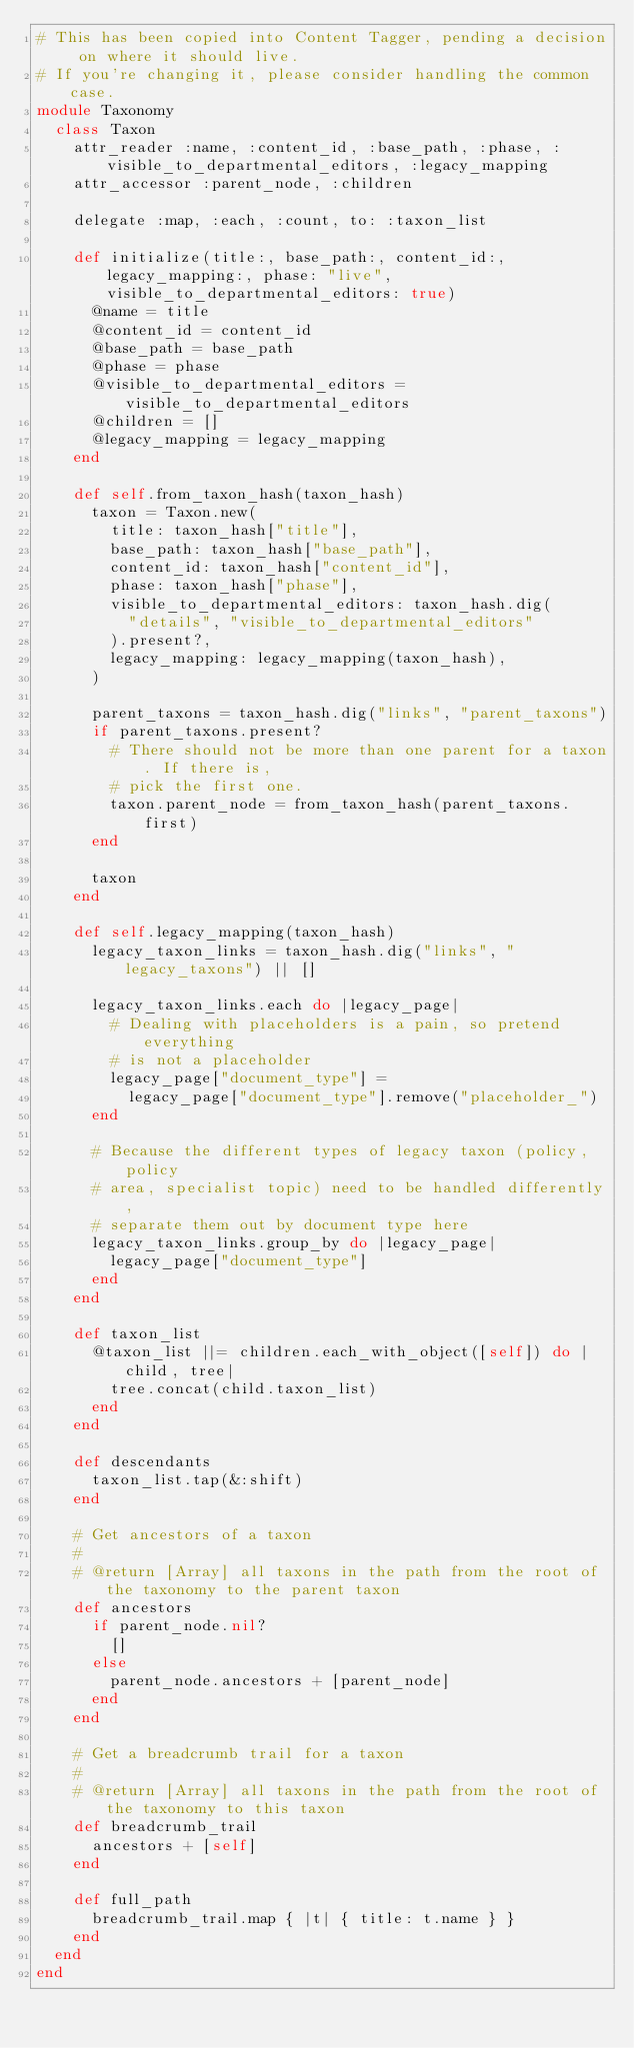Convert code to text. <code><loc_0><loc_0><loc_500><loc_500><_Ruby_># This has been copied into Content Tagger, pending a decision on where it should live.
# If you're changing it, please consider handling the common case.
module Taxonomy
  class Taxon
    attr_reader :name, :content_id, :base_path, :phase, :visible_to_departmental_editors, :legacy_mapping
    attr_accessor :parent_node, :children

    delegate :map, :each, :count, to: :taxon_list

    def initialize(title:, base_path:, content_id:, legacy_mapping:, phase: "live", visible_to_departmental_editors: true)
      @name = title
      @content_id = content_id
      @base_path = base_path
      @phase = phase
      @visible_to_departmental_editors = visible_to_departmental_editors
      @children = []
      @legacy_mapping = legacy_mapping
    end

    def self.from_taxon_hash(taxon_hash)
      taxon = Taxon.new(
        title: taxon_hash["title"],
        base_path: taxon_hash["base_path"],
        content_id: taxon_hash["content_id"],
        phase: taxon_hash["phase"],
        visible_to_departmental_editors: taxon_hash.dig(
          "details", "visible_to_departmental_editors"
        ).present?,
        legacy_mapping: legacy_mapping(taxon_hash),
      )

      parent_taxons = taxon_hash.dig("links", "parent_taxons")
      if parent_taxons.present?
        # There should not be more than one parent for a taxon. If there is,
        # pick the first one.
        taxon.parent_node = from_taxon_hash(parent_taxons.first)
      end

      taxon
    end

    def self.legacy_mapping(taxon_hash)
      legacy_taxon_links = taxon_hash.dig("links", "legacy_taxons") || []

      legacy_taxon_links.each do |legacy_page|
        # Dealing with placeholders is a pain, so pretend everything
        # is not a placeholder
        legacy_page["document_type"] =
          legacy_page["document_type"].remove("placeholder_")
      end

      # Because the different types of legacy taxon (policy, policy
      # area, specialist topic) need to be handled differently,
      # separate them out by document type here
      legacy_taxon_links.group_by do |legacy_page|
        legacy_page["document_type"]
      end
    end

    def taxon_list
      @taxon_list ||= children.each_with_object([self]) do |child, tree|
        tree.concat(child.taxon_list)
      end
    end

    def descendants
      taxon_list.tap(&:shift)
    end

    # Get ancestors of a taxon
    #
    # @return [Array] all taxons in the path from the root of the taxonomy to the parent taxon
    def ancestors
      if parent_node.nil?
        []
      else
        parent_node.ancestors + [parent_node]
      end
    end

    # Get a breadcrumb trail for a taxon
    #
    # @return [Array] all taxons in the path from the root of the taxonomy to this taxon
    def breadcrumb_trail
      ancestors + [self]
    end

    def full_path
      breadcrumb_trail.map { |t| { title: t.name } }
    end
  end
end
</code> 